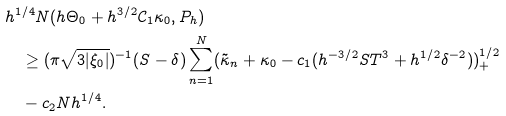<formula> <loc_0><loc_0><loc_500><loc_500>& h ^ { 1 / 4 } N ( h \Theta _ { 0 } + h ^ { 3 / 2 } \mathcal { C } _ { 1 } \kappa _ { 0 } , P _ { h } ) \\ & \quad \geq ( \pi \sqrt { 3 | \xi _ { 0 } | } ) ^ { - 1 } ( S - \delta ) \sum _ { n = 1 } ^ { N } ( \tilde { \kappa } _ { n } + \kappa _ { 0 } - c _ { 1 } ( h ^ { - 3 / 2 } S T ^ { 3 } + h ^ { 1 / 2 } \delta ^ { - 2 } ) ) _ { + } ^ { 1 / 2 } \\ & \quad - c _ { 2 } N h ^ { 1 / 4 } .</formula> 